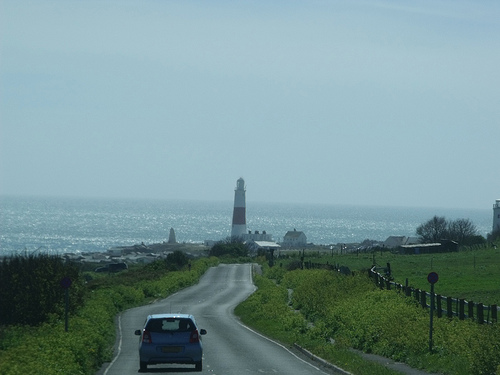<image>
Is the car on the ocean? No. The car is not positioned on the ocean. They may be near each other, but the car is not supported by or resting on top of the ocean. Is the sea behind the light house? Yes. From this viewpoint, the sea is positioned behind the light house, with the light house partially or fully occluding the sea. 